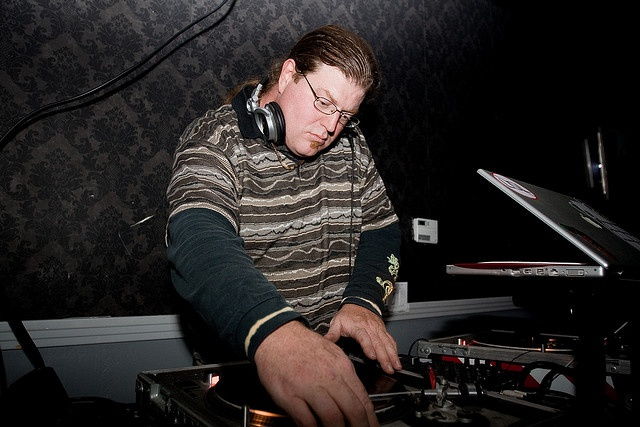Describe the objects in this image and their specific colors. I can see people in black, gray, and darkgray tones and laptop in black, gray, darkgray, and lightgray tones in this image. 